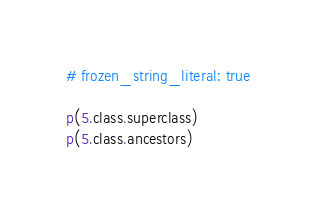Convert code to text. <code><loc_0><loc_0><loc_500><loc_500><_Ruby_># frozen_string_literal: true

p(5.class.superclass)
p(5.class.ancestors)
</code> 